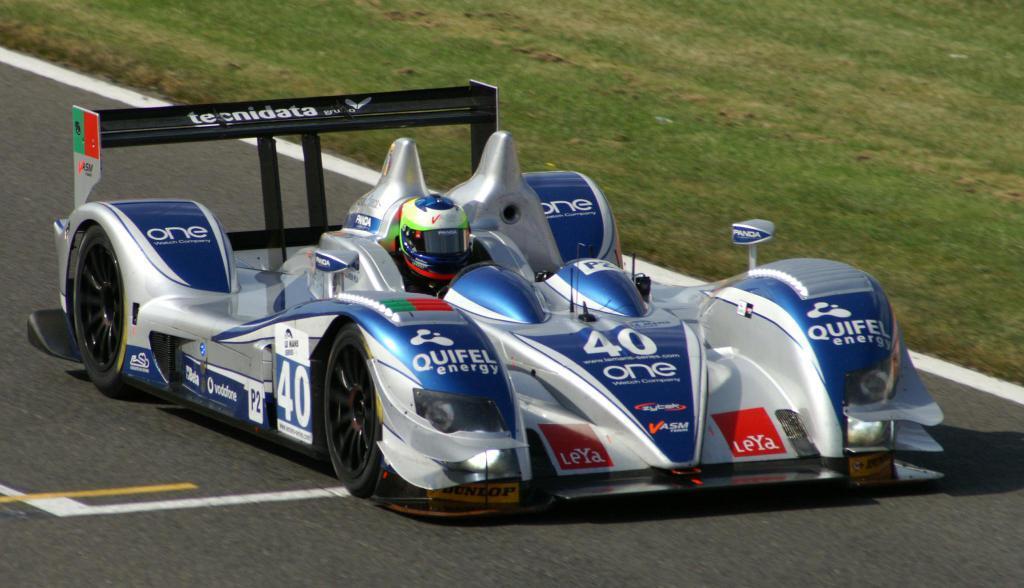In one or two sentences, can you explain what this image depicts? In this picture we can see a vehicle on the road with a person on it and in the background we can see grass. 